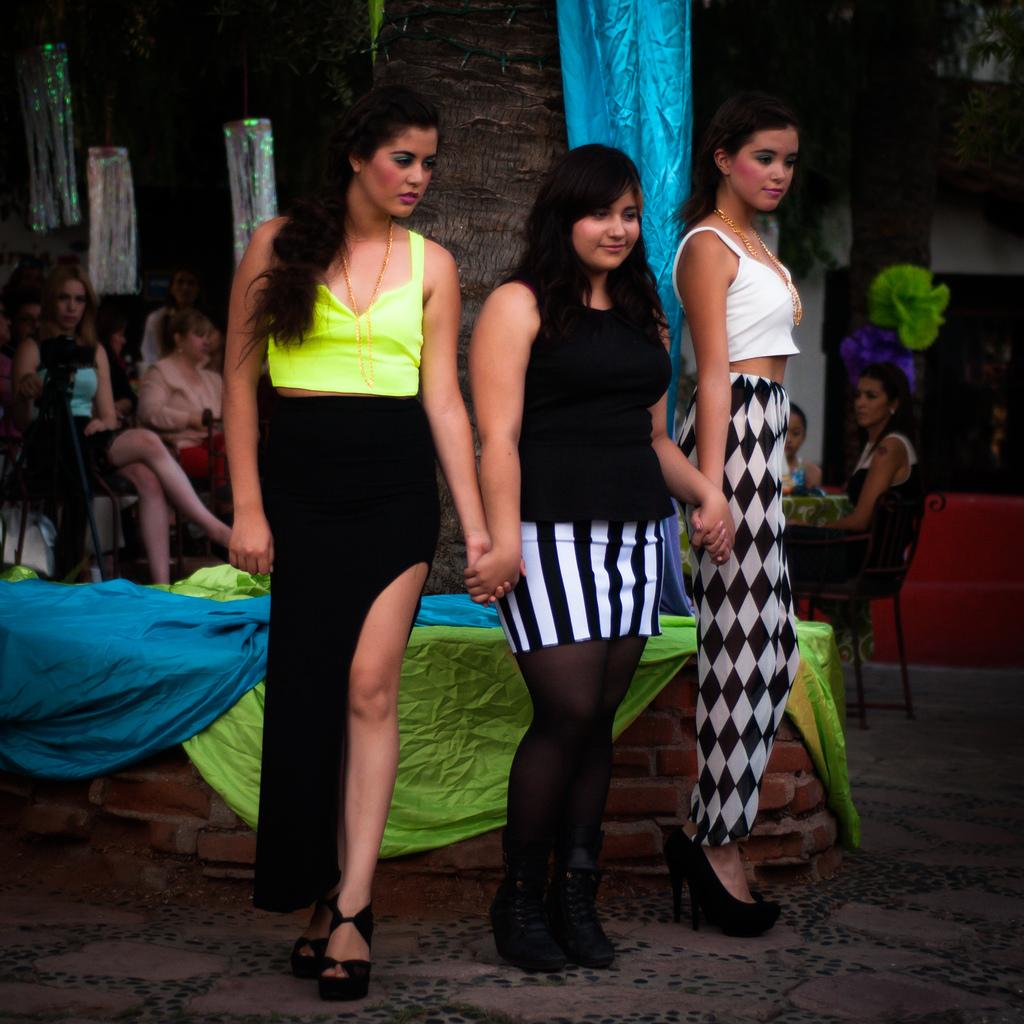How many women are in the image? There are three women in the image. What are the women doing in the image? The women are standing and smiling. What can be seen in the background of the image? There is a tree in the background of the image. Are there any other people in the image besides the three women? Yes, there are people sitting and watching behind the tree. What type of polish is being applied to the line in the image? There is no polish or line present in the image. How many times do the women fold their arms in the image? The women are not folding their arms in the image; they are standing and smiling with their arms at their sides. 